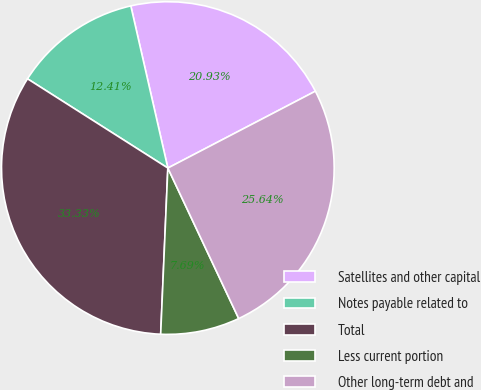Convert chart. <chart><loc_0><loc_0><loc_500><loc_500><pie_chart><fcel>Satellites and other capital<fcel>Notes payable related to<fcel>Total<fcel>Less current portion<fcel>Other long-term debt and<nl><fcel>20.93%<fcel>12.41%<fcel>33.33%<fcel>7.69%<fcel>25.64%<nl></chart> 